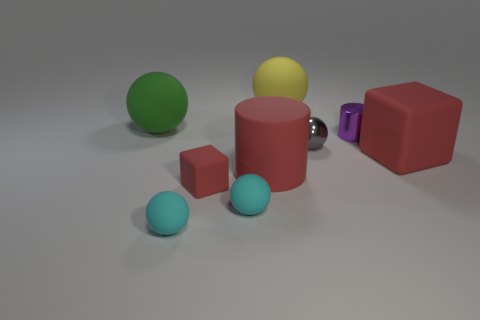Subtract all yellow spheres. How many spheres are left? 4 Subtract all big yellow rubber balls. How many balls are left? 4 Subtract all cyan cylinders. Subtract all red cubes. How many cylinders are left? 2 Add 1 green rubber spheres. How many objects exist? 10 Subtract all cylinders. How many objects are left? 7 Subtract all big cyan metal cylinders. Subtract all metallic balls. How many objects are left? 8 Add 1 large green rubber objects. How many large green rubber objects are left? 2 Add 7 yellow matte spheres. How many yellow matte spheres exist? 8 Subtract 0 purple cubes. How many objects are left? 9 